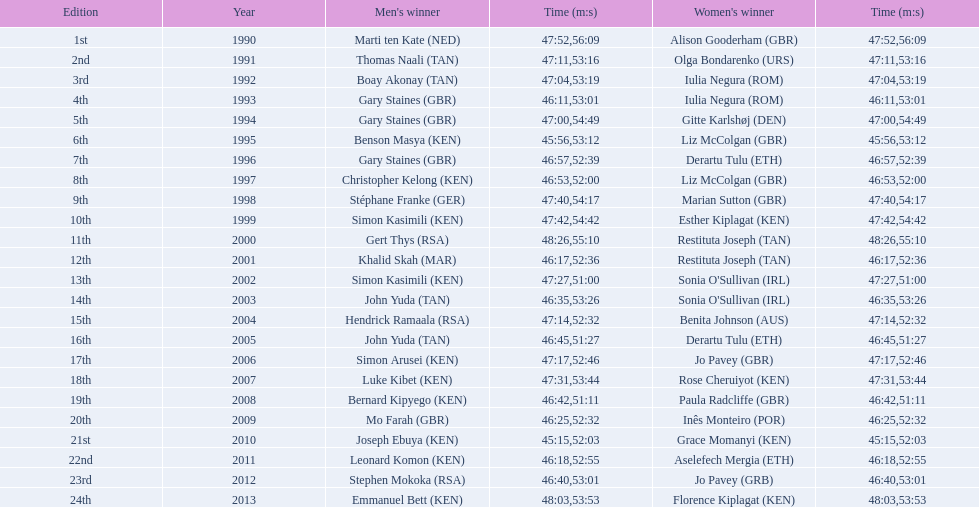What is the appellation of the earliest women's winner? Alison Gooderham. 